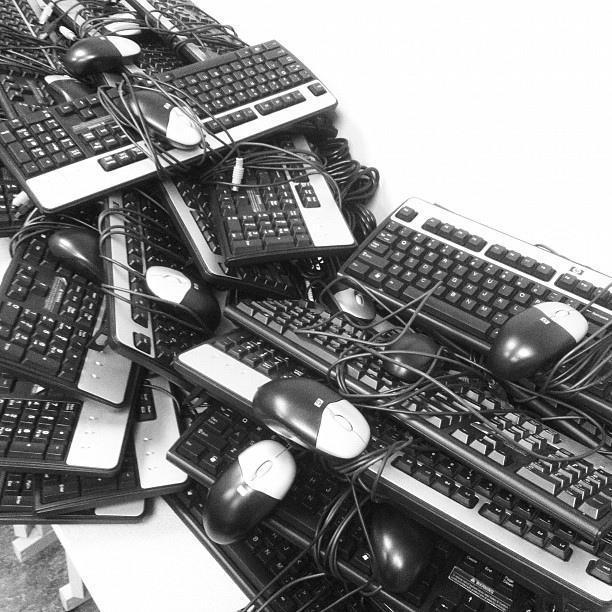How many keyboards are there?
Give a very brief answer. 13. How many mice can be seen?
Give a very brief answer. 9. How many polo bears are in the image?
Give a very brief answer. 0. 